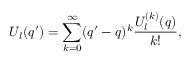<formula> <loc_0><loc_0><loc_500><loc_500>U _ { l } ( q ^ { \prime } ) = \sum _ { k = 0 } ^ { \infty } ( q ^ { \prime } - q ) ^ { k } \frac { U _ { l } ^ { ( k ) } ( q ) } { k ! } ,</formula> 